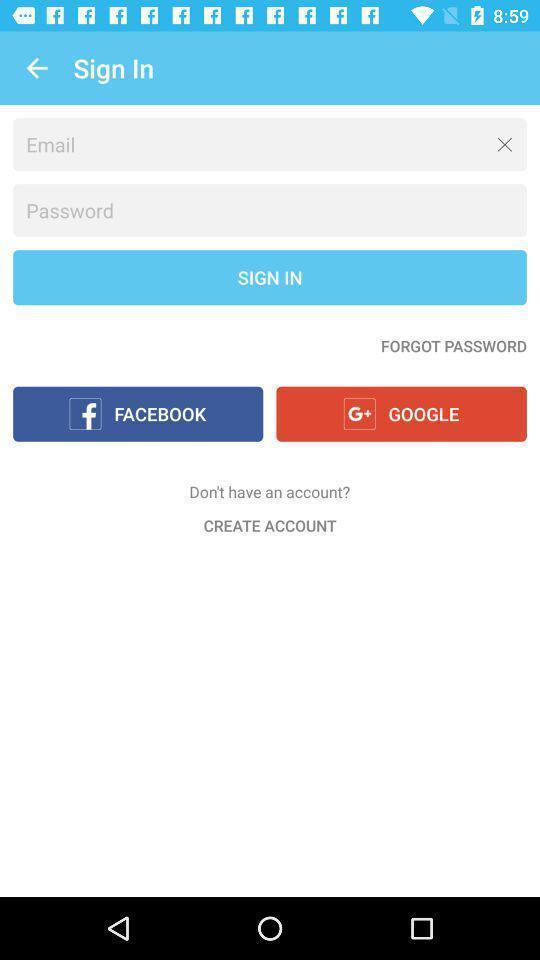What is the overall content of this screenshot? Sign in page to enter credentials. 